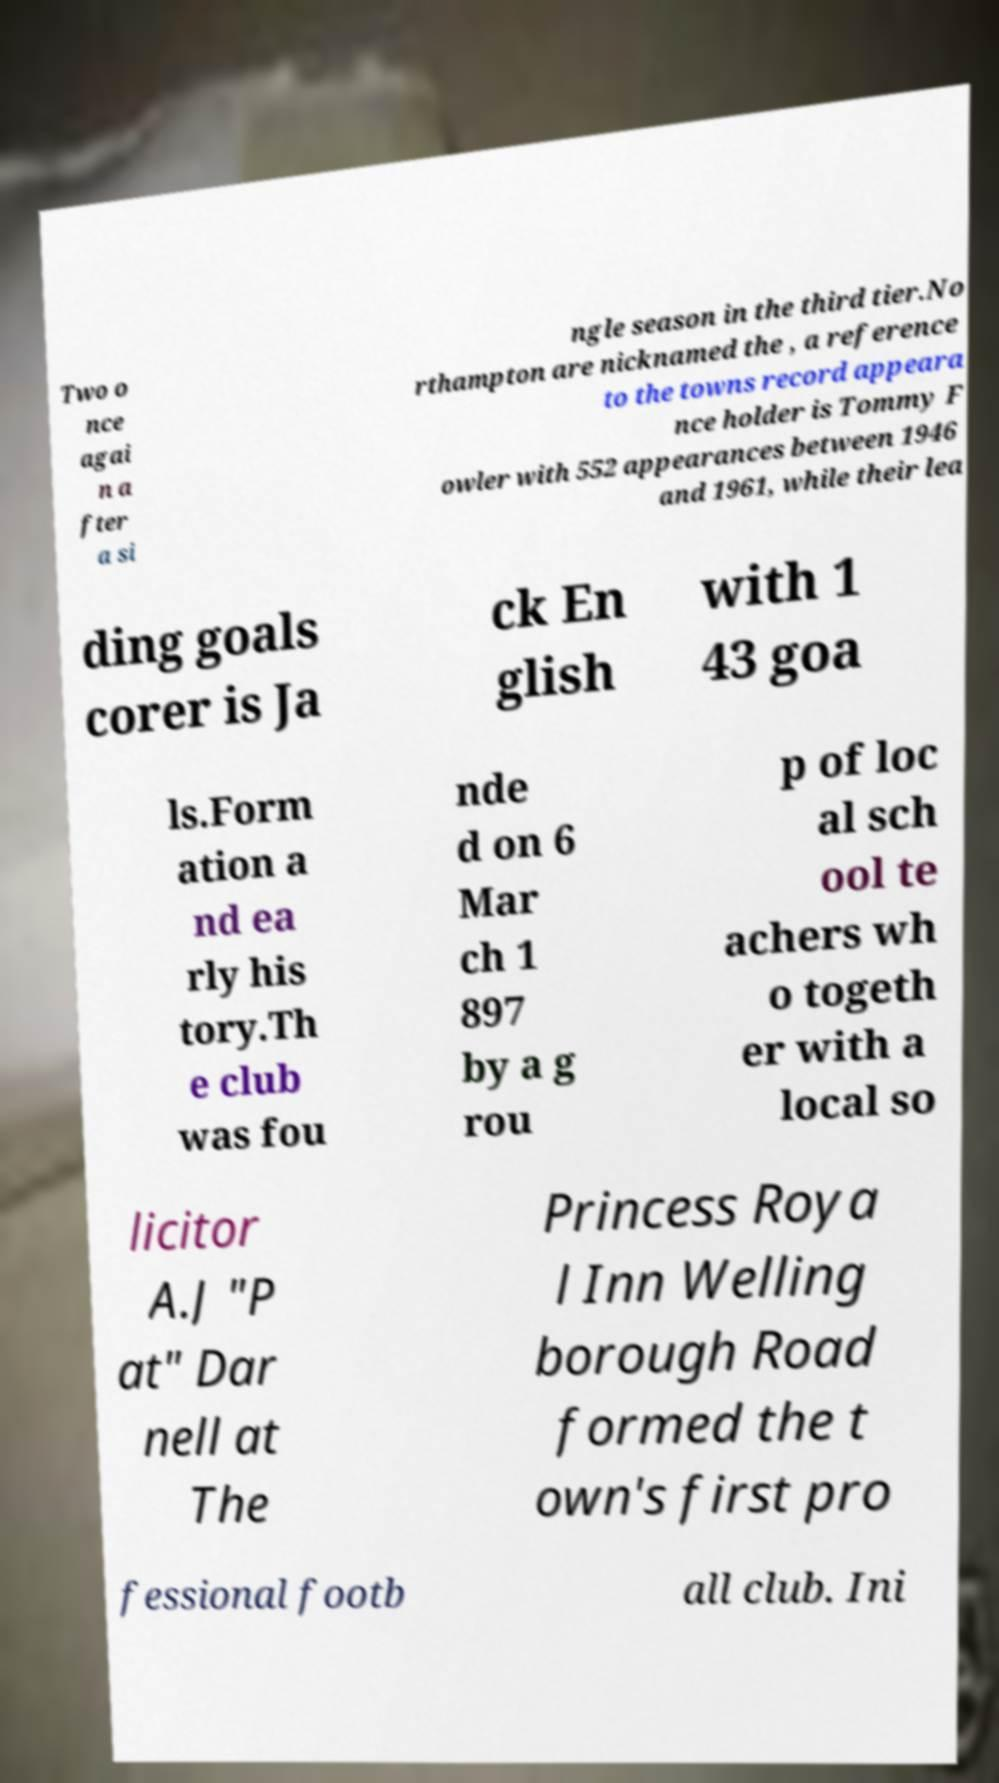Can you read and provide the text displayed in the image?This photo seems to have some interesting text. Can you extract and type it out for me? Two o nce agai n a fter a si ngle season in the third tier.No rthampton are nicknamed the , a reference to the towns record appeara nce holder is Tommy F owler with 552 appearances between 1946 and 1961, while their lea ding goals corer is Ja ck En glish with 1 43 goa ls.Form ation a nd ea rly his tory.Th e club was fou nde d on 6 Mar ch 1 897 by a g rou p of loc al sch ool te achers wh o togeth er with a local so licitor A.J "P at" Dar nell at The Princess Roya l Inn Welling borough Road formed the t own's first pro fessional footb all club. Ini 